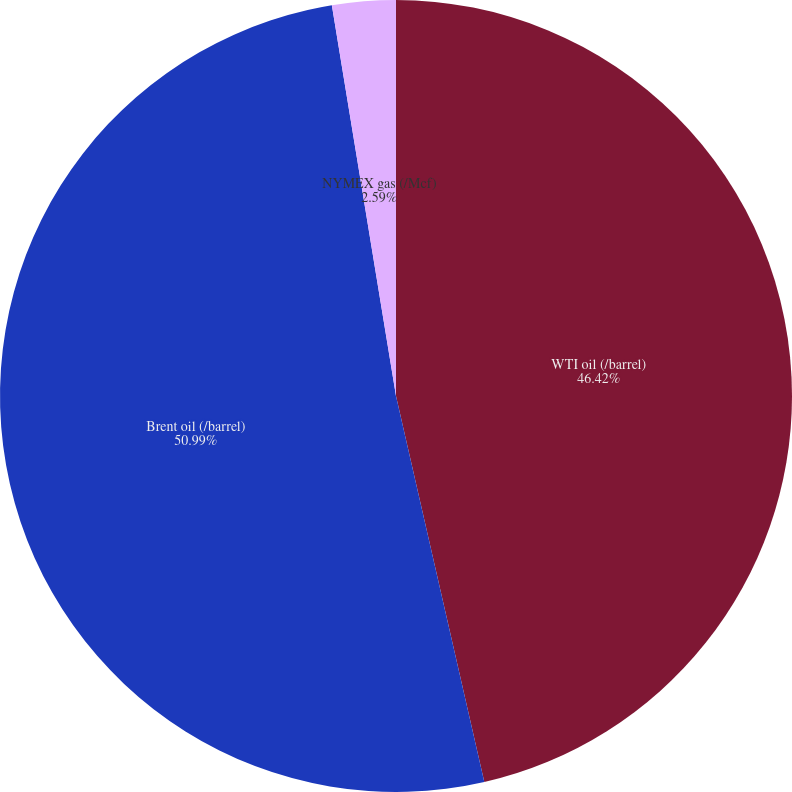<chart> <loc_0><loc_0><loc_500><loc_500><pie_chart><fcel>WTI oil (/barrel)<fcel>Brent oil (/barrel)<fcel>NYMEX gas (/Mcf)<nl><fcel>46.42%<fcel>50.99%<fcel>2.59%<nl></chart> 